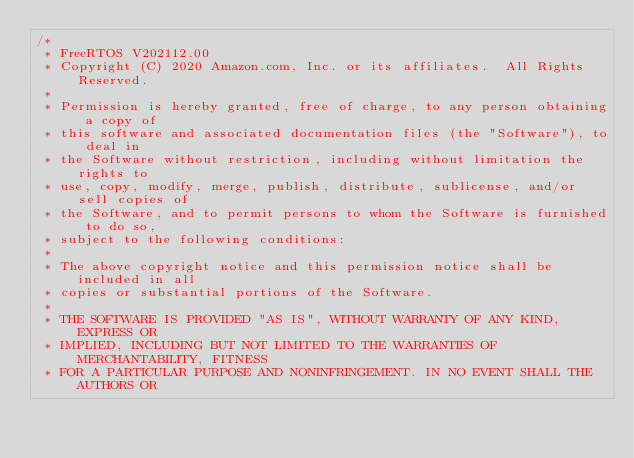Convert code to text. <code><loc_0><loc_0><loc_500><loc_500><_C_>/*
 * FreeRTOS V202112.00
 * Copyright (C) 2020 Amazon.com, Inc. or its affiliates.  All Rights Reserved.
 *
 * Permission is hereby granted, free of charge, to any person obtaining a copy of
 * this software and associated documentation files (the "Software"), to deal in
 * the Software without restriction, including without limitation the rights to
 * use, copy, modify, merge, publish, distribute, sublicense, and/or sell copies of
 * the Software, and to permit persons to whom the Software is furnished to do so,
 * subject to the following conditions:
 *
 * The above copyright notice and this permission notice shall be included in all
 * copies or substantial portions of the Software.
 *
 * THE SOFTWARE IS PROVIDED "AS IS", WITHOUT WARRANTY OF ANY KIND, EXPRESS OR
 * IMPLIED, INCLUDING BUT NOT LIMITED TO THE WARRANTIES OF MERCHANTABILITY, FITNESS
 * FOR A PARTICULAR PURPOSE AND NONINFRINGEMENT. IN NO EVENT SHALL THE AUTHORS OR</code> 